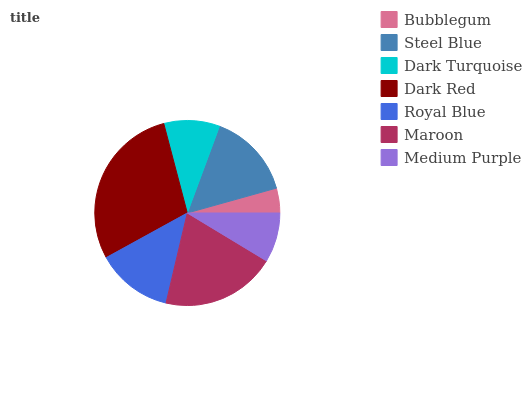Is Bubblegum the minimum?
Answer yes or no. Yes. Is Dark Red the maximum?
Answer yes or no. Yes. Is Steel Blue the minimum?
Answer yes or no. No. Is Steel Blue the maximum?
Answer yes or no. No. Is Steel Blue greater than Bubblegum?
Answer yes or no. Yes. Is Bubblegum less than Steel Blue?
Answer yes or no. Yes. Is Bubblegum greater than Steel Blue?
Answer yes or no. No. Is Steel Blue less than Bubblegum?
Answer yes or no. No. Is Royal Blue the high median?
Answer yes or no. Yes. Is Royal Blue the low median?
Answer yes or no. Yes. Is Steel Blue the high median?
Answer yes or no. No. Is Steel Blue the low median?
Answer yes or no. No. 